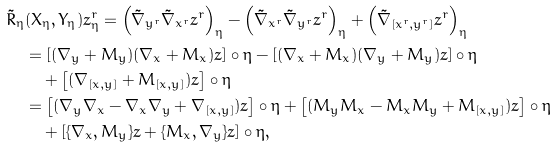<formula> <loc_0><loc_0><loc_500><loc_500>\tilde { R } _ { \eta } & ( X _ { \eta } , Y _ { \eta } ) z ^ { r } _ { \eta } = \left ( \tilde { \nabla } _ { y ^ { r } } \tilde { \nabla } _ { x ^ { r } } z ^ { r } \right ) _ { \eta } - \left ( \tilde { \nabla } _ { x ^ { r } } \tilde { \nabla } _ { y ^ { r } } z ^ { r } \right ) _ { \eta } + \left ( \tilde { \nabla } _ { [ x ^ { r } , y ^ { r } ] } z ^ { r } \right ) _ { \eta } \\ & = \left [ ( \nabla _ { y } + M _ { y } ) ( \nabla _ { x } + M _ { x } ) z \right ] \circ \eta - \left [ ( \nabla _ { x } + M _ { x } ) ( \nabla _ { y } + M _ { y } ) z \right ] \circ \eta \\ & \quad + \left [ ( \nabla _ { [ x , y ] } + M _ { [ x , y ] } ) z \right ] \circ \eta \\ & = \left [ ( \nabla _ { y } \nabla _ { x } - \nabla _ { x } \nabla _ { y } + \nabla _ { [ x , y ] } ) z \right ] \circ \eta + \left [ ( M _ { y } M _ { x } - M _ { x } M _ { y } + M _ { [ x , y ] } ) z \right ] \circ \eta \\ & \quad + \left [ \{ \nabla _ { x } , M _ { y } \} z + \{ M _ { x } , \nabla _ { y } \} z \right ] \circ \eta ,</formula> 